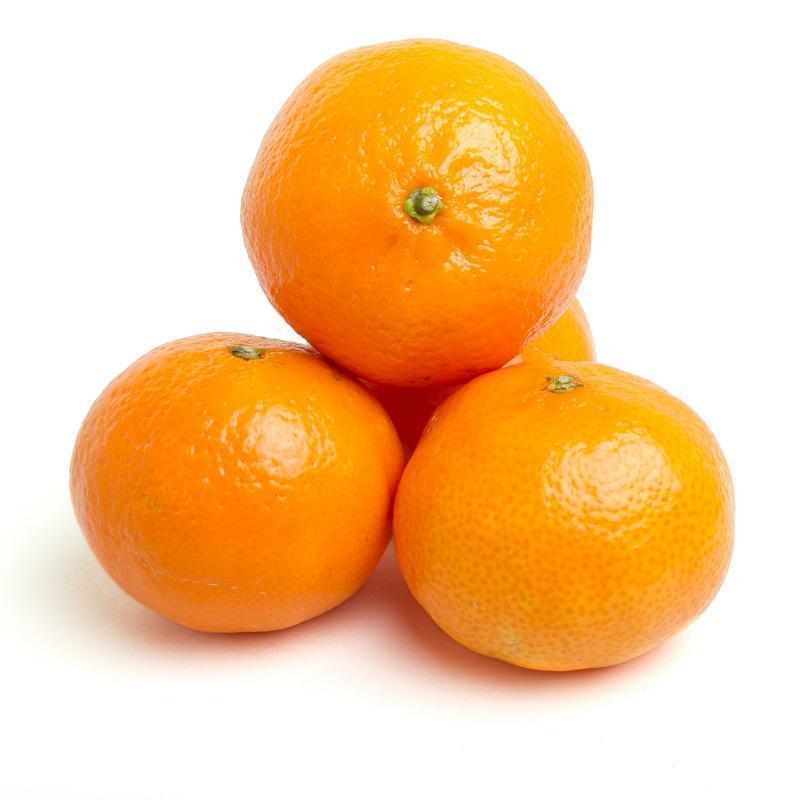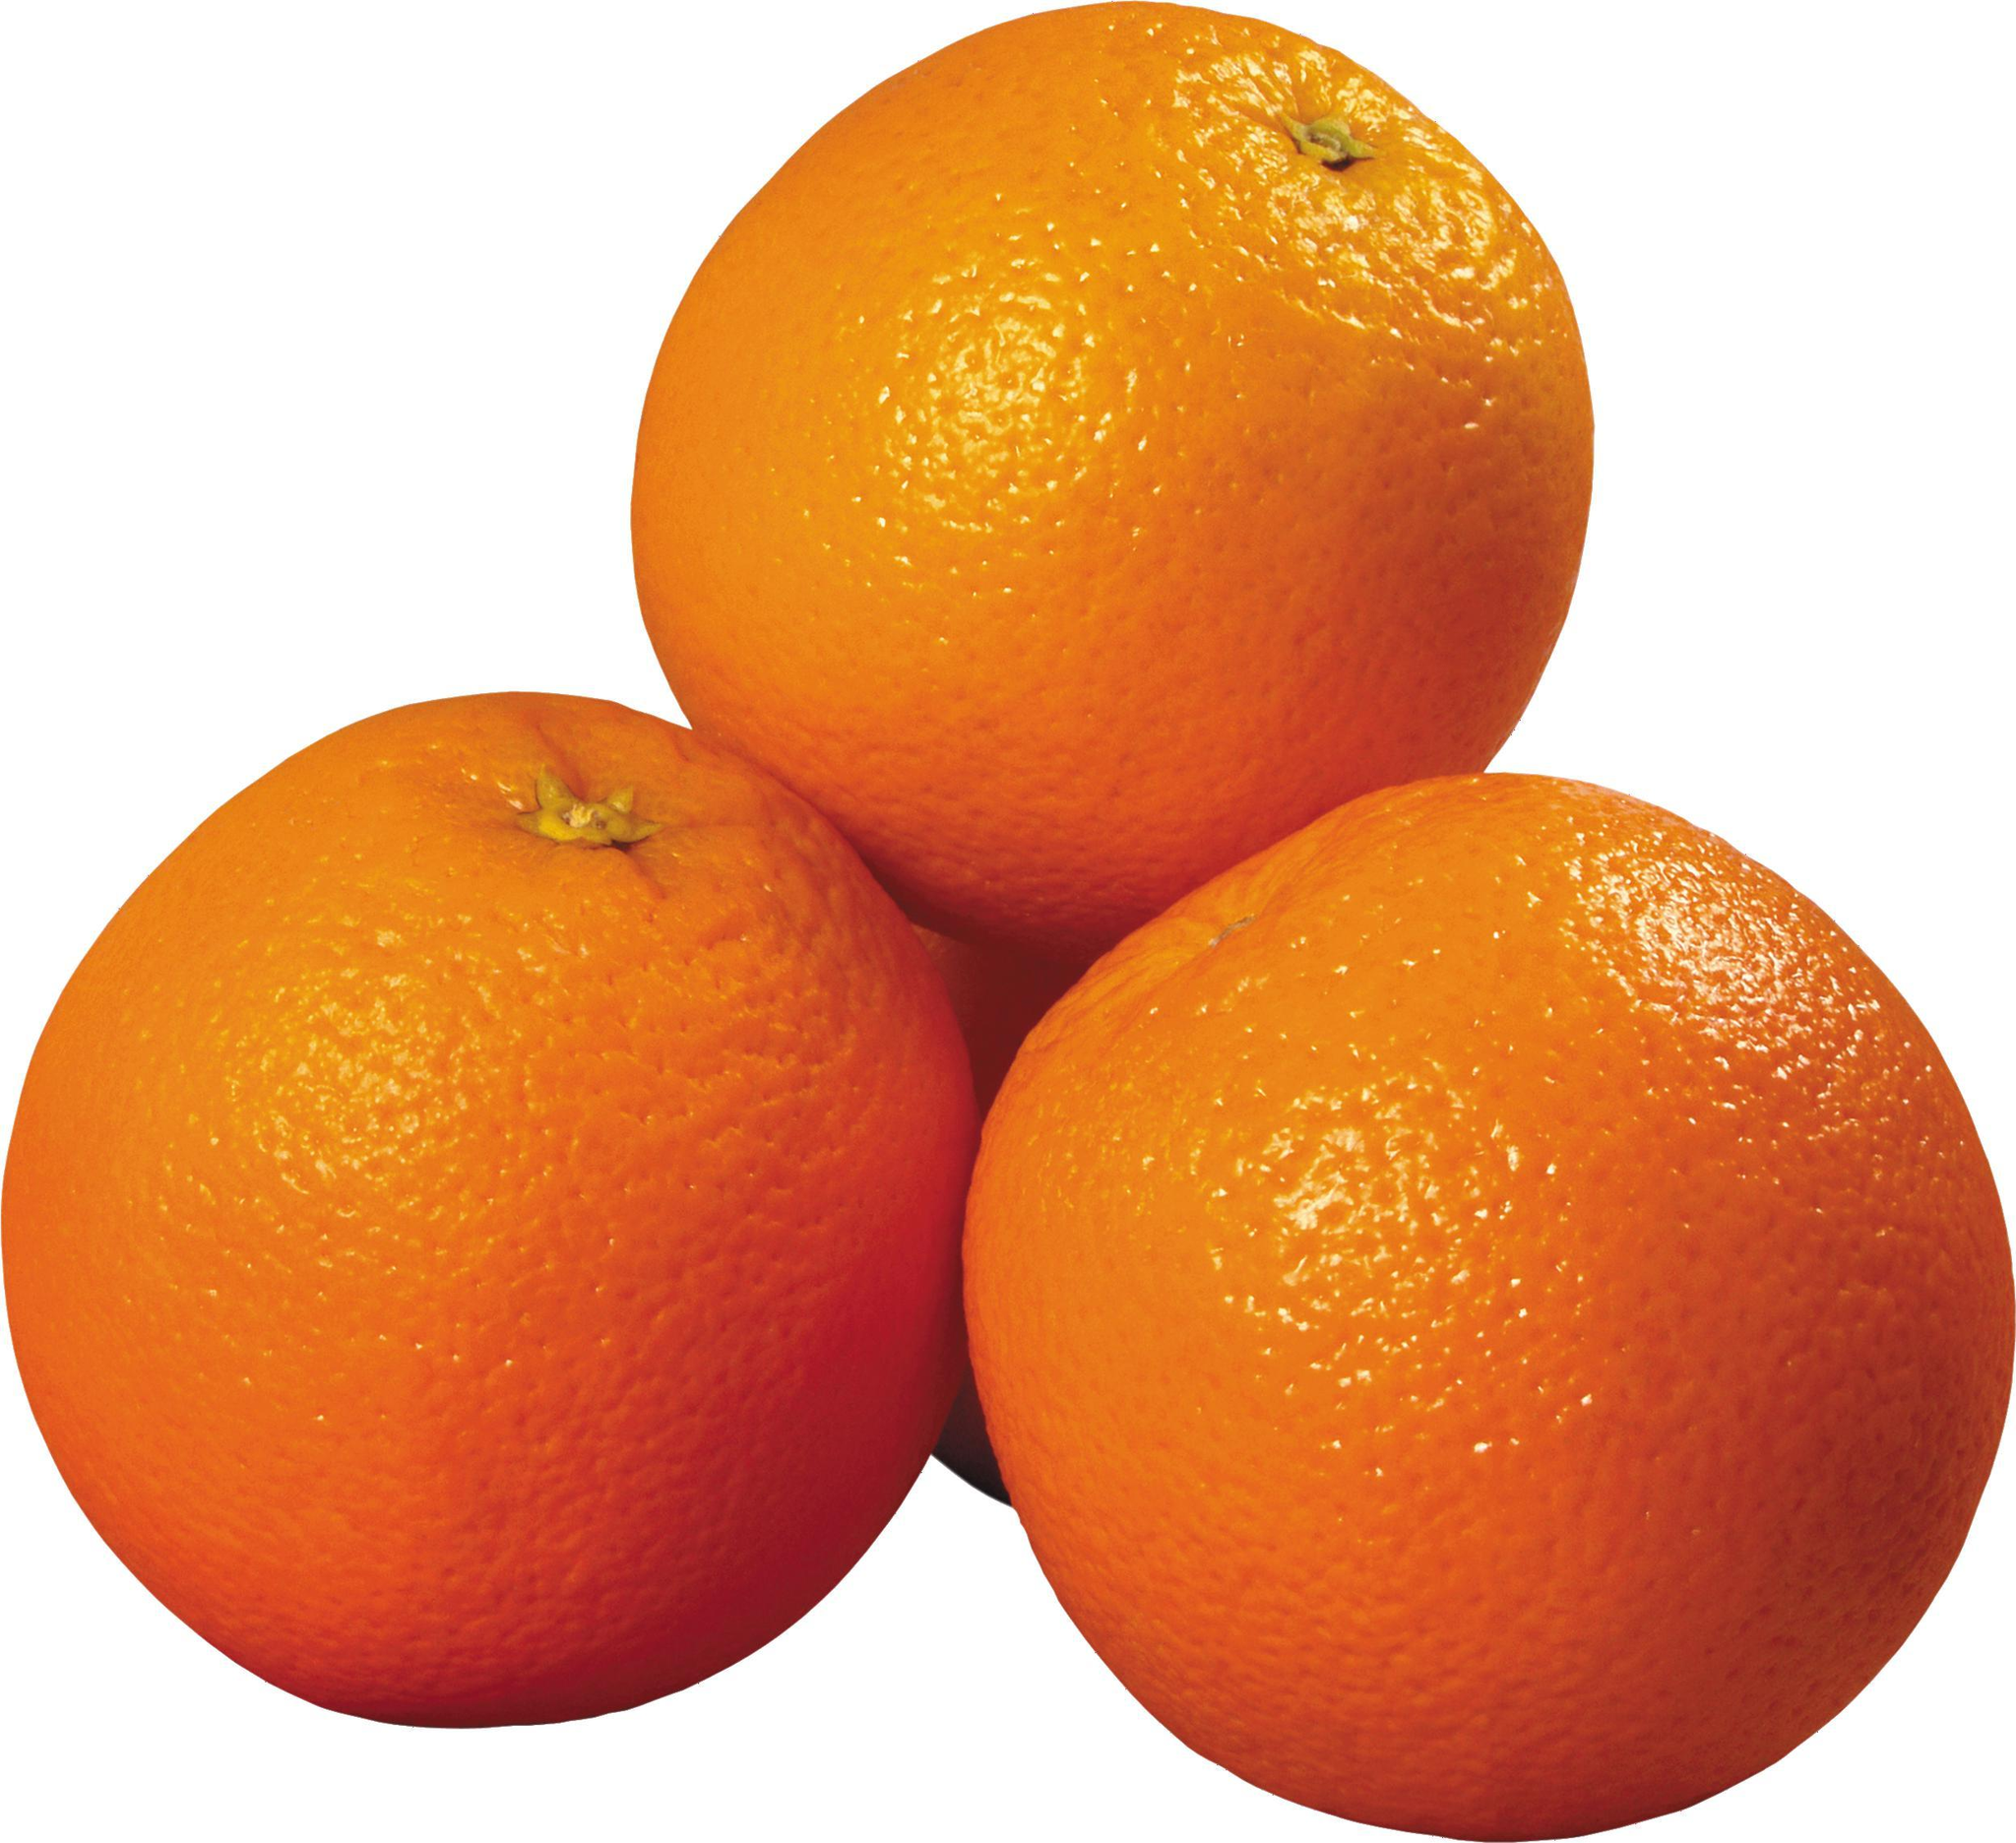The first image is the image on the left, the second image is the image on the right. For the images displayed, is the sentence "There are at most 6 oranges total" factually correct? Answer yes or no. No. The first image is the image on the left, the second image is the image on the right. Assess this claim about the two images: "There are six oranges.". Correct or not? Answer yes or no. No. 